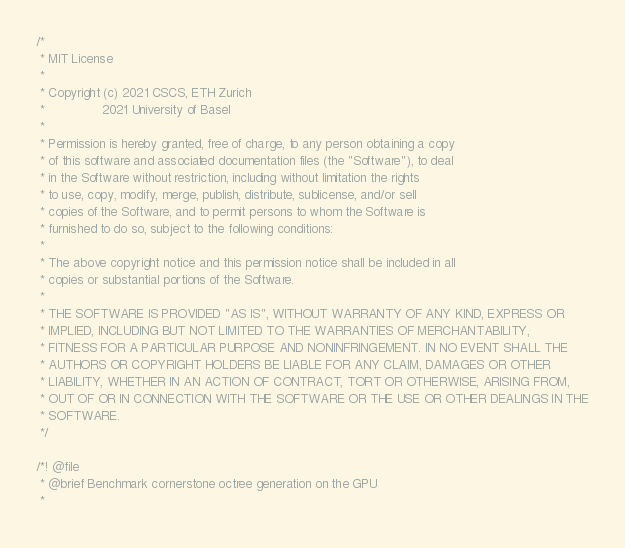<code> <loc_0><loc_0><loc_500><loc_500><_Cuda_>/*
 * MIT License
 *
 * Copyright (c) 2021 CSCS, ETH Zurich
 *               2021 University of Basel
 *
 * Permission is hereby granted, free of charge, to any person obtaining a copy
 * of this software and associated documentation files (the "Software"), to deal
 * in the Software without restriction, including without limitation the rights
 * to use, copy, modify, merge, publish, distribute, sublicense, and/or sell
 * copies of the Software, and to permit persons to whom the Software is
 * furnished to do so, subject to the following conditions:
 *
 * The above copyright notice and this permission notice shall be included in all
 * copies or substantial portions of the Software.
 *
 * THE SOFTWARE IS PROVIDED "AS IS", WITHOUT WARRANTY OF ANY KIND, EXPRESS OR
 * IMPLIED, INCLUDING BUT NOT LIMITED TO THE WARRANTIES OF MERCHANTABILITY,
 * FITNESS FOR A PARTICULAR PURPOSE AND NONINFRINGEMENT. IN NO EVENT SHALL THE
 * AUTHORS OR COPYRIGHT HOLDERS BE LIABLE FOR ANY CLAIM, DAMAGES OR OTHER
 * LIABILITY, WHETHER IN AN ACTION OF CONTRACT, TORT OR OTHERWISE, ARISING FROM,
 * OUT OF OR IN CONNECTION WITH THE SOFTWARE OR THE USE OR OTHER DEALINGS IN THE
 * SOFTWARE.
 */

/*! @file
 * @brief Benchmark cornerstone octree generation on the GPU
 *</code> 